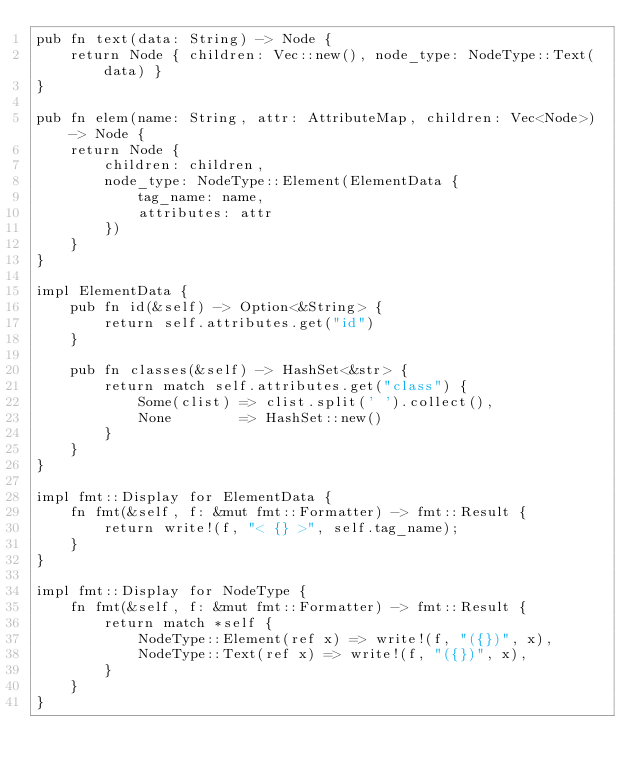Convert code to text. <code><loc_0><loc_0><loc_500><loc_500><_Rust_>pub fn text(data: String) -> Node {
    return Node { children: Vec::new(), node_type: NodeType::Text(data) }
}

pub fn elem(name: String, attr: AttributeMap, children: Vec<Node>) -> Node {
    return Node {
        children: children,
        node_type: NodeType::Element(ElementData {
            tag_name: name,
            attributes: attr
        })
    }
}

impl ElementData {
    pub fn id(&self) -> Option<&String> {
        return self.attributes.get("id")
    }

    pub fn classes(&self) -> HashSet<&str> {
        return match self.attributes.get("class") {
            Some(clist) => clist.split(' ').collect(),
            None        => HashSet::new()
        }
    }
}

impl fmt::Display for ElementData {
    fn fmt(&self, f: &mut fmt::Formatter) -> fmt::Result {
        return write!(f, "< {} >", self.tag_name);
    }
}

impl fmt::Display for NodeType {
    fn fmt(&self, f: &mut fmt::Formatter) -> fmt::Result {
        return match *self {
            NodeType::Element(ref x) => write!(f, "({})", x),
            NodeType::Text(ref x) => write!(f, "({})", x),
        }
    }
}
</code> 